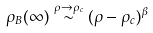Convert formula to latex. <formula><loc_0><loc_0><loc_500><loc_500>\rho _ { B } ( \infty ) \stackrel { \rho \rightarrow \rho _ { c } } { \sim } ( \rho - \rho _ { c } ) ^ { \beta }</formula> 